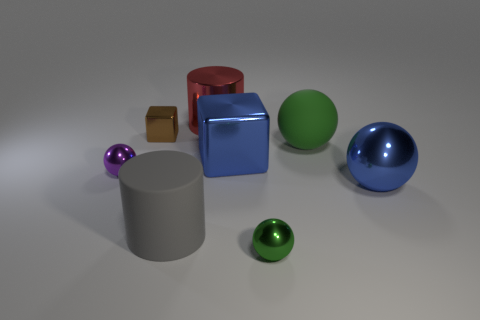Is there any other thing that has the same color as the big metallic block?
Ensure brevity in your answer.  Yes. What material is the tiny thing that is right of the purple ball and to the left of the big red object?
Your answer should be very brief. Metal. Is the shape of the green matte object the same as the small shiny object that is on the right side of the red thing?
Ensure brevity in your answer.  Yes. There is a large ball behind the ball that is left of the metallic block in front of the small metallic cube; what is it made of?
Your answer should be compact. Rubber. What number of other things are the same size as the gray rubber cylinder?
Keep it short and to the point. 4. Do the large metal ball and the large metallic cube have the same color?
Your response must be concise. Yes. How many blue shiny things are in front of the blue thing that is to the left of the small object that is on the right side of the red cylinder?
Ensure brevity in your answer.  1. There is a green sphere behind the block that is right of the brown thing; what is it made of?
Offer a very short reply. Rubber. Are there any small purple metallic objects that have the same shape as the brown object?
Make the answer very short. No. What is the color of the other rubber cylinder that is the same size as the red cylinder?
Ensure brevity in your answer.  Gray. 